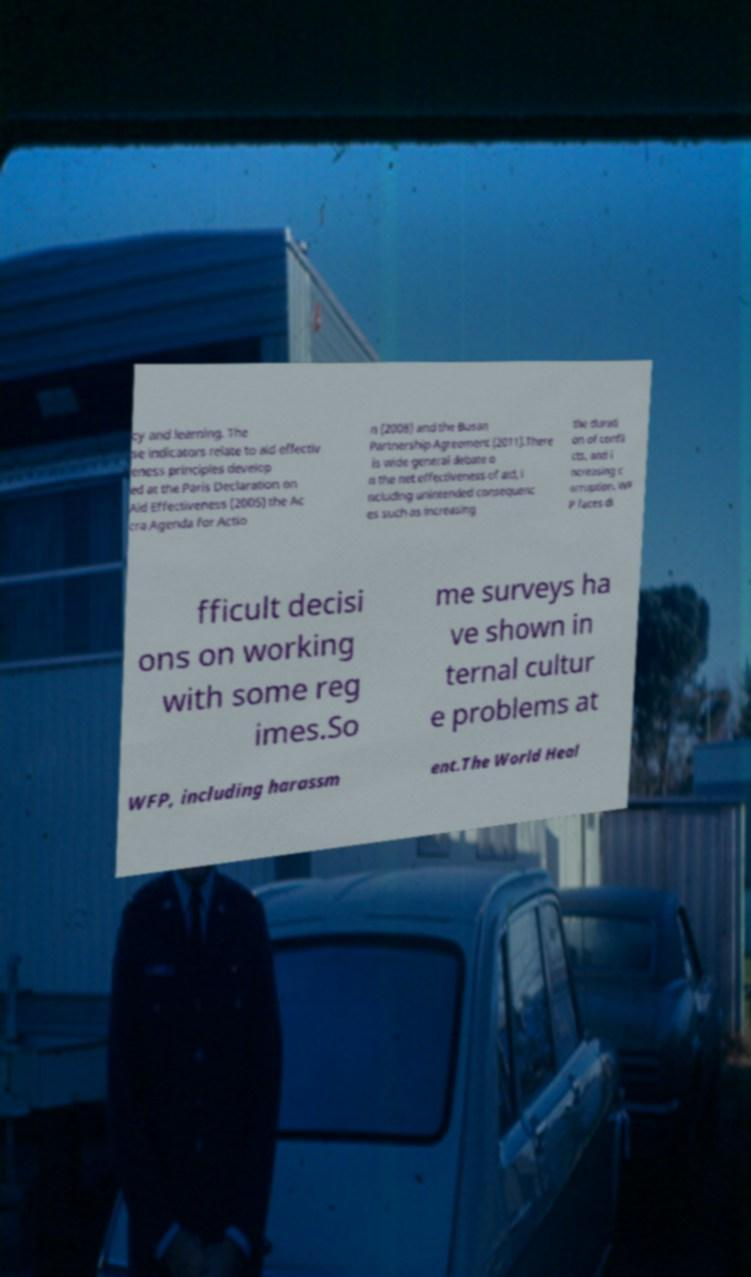What messages or text are displayed in this image? I need them in a readable, typed format. cy and learning. The se indicators relate to aid effectiv eness principles develop ed at the Paris Declaration on Aid Effectiveness (2005) the Ac cra Agenda for Actio n (2008) and the Busan Partnership Agreement (2011).There is wide general debate o n the net effectiveness of aid, i ncluding unintended consequenc es such as increasing the durati on of confli cts, and i ncreasing c orruption. WF P faces di fficult decisi ons on working with some reg imes.So me surveys ha ve shown in ternal cultur e problems at WFP, including harassm ent.The World Heal 